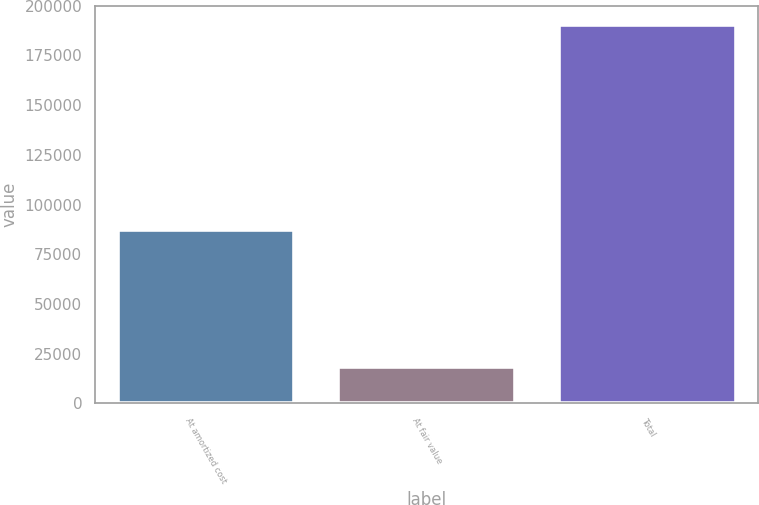Convert chart. <chart><loc_0><loc_0><loc_500><loc_500><bar_chart><fcel>At amortized cost<fcel>At fair value<fcel>Total<nl><fcel>86951<fcel>18207<fcel>190482<nl></chart> 